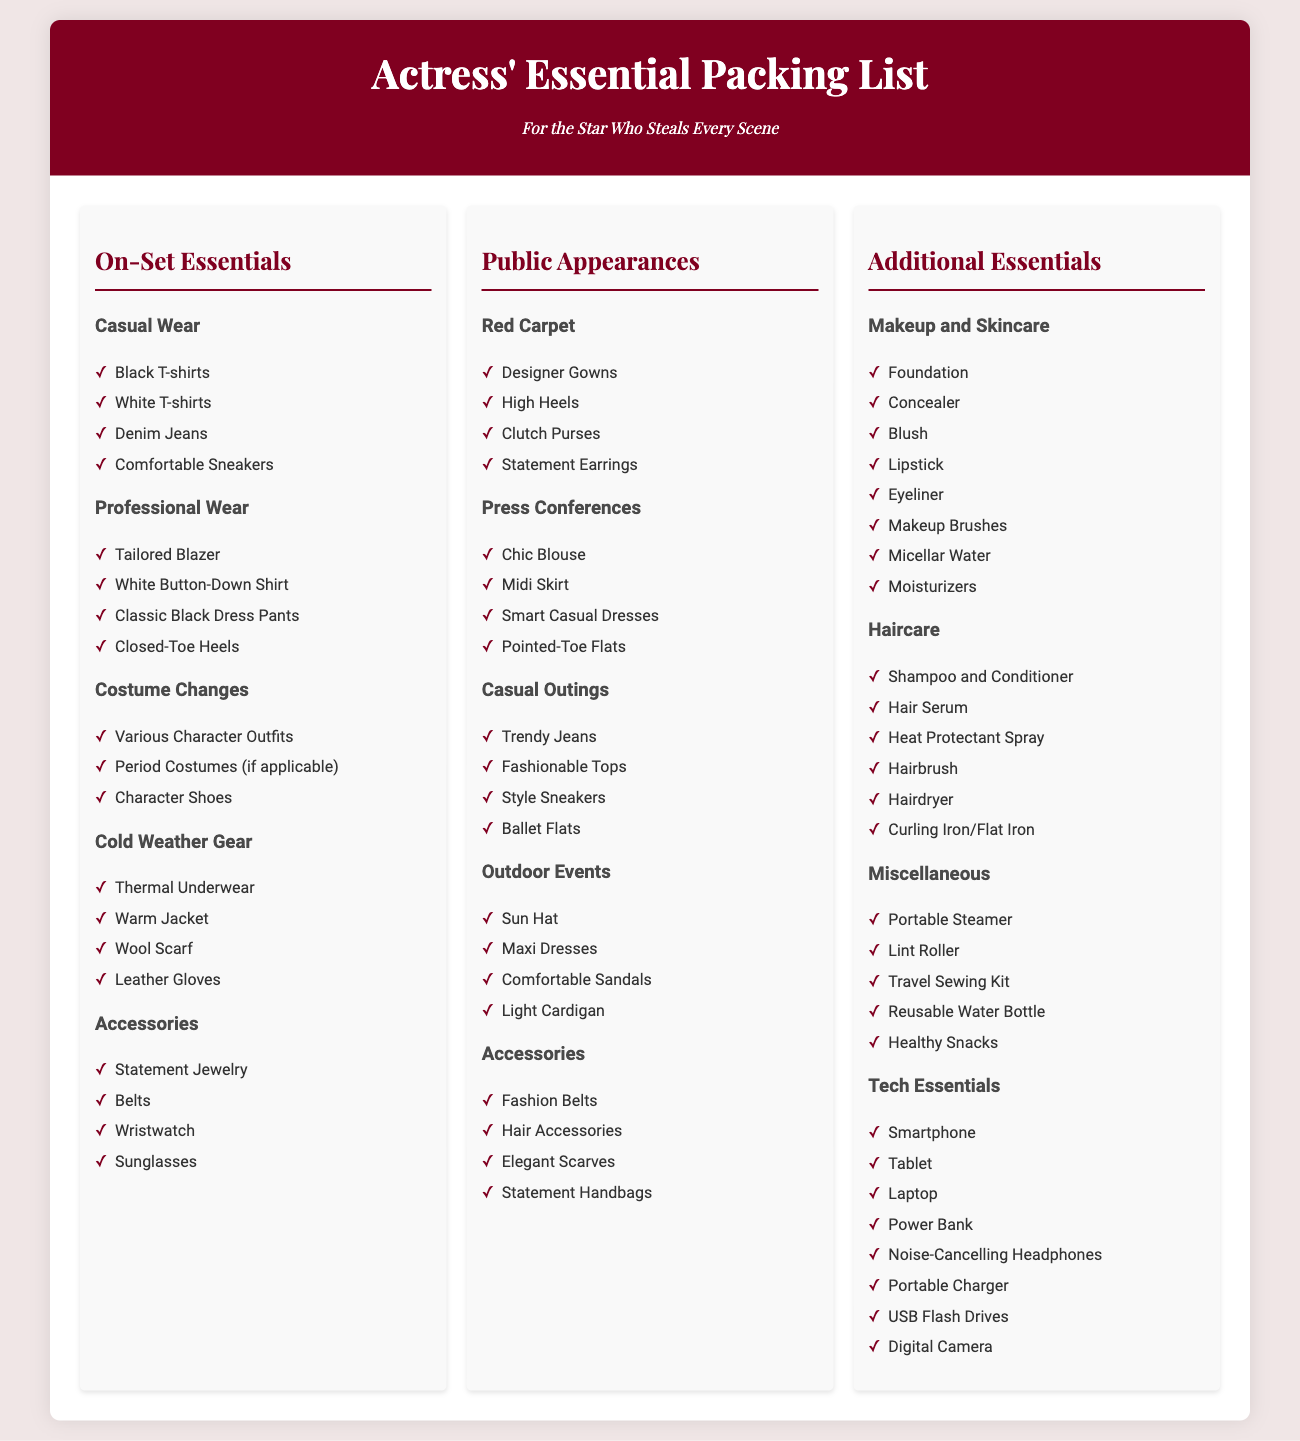what are the categories listed under On-Set Essentials? The categories listed are Casual Wear, Professional Wear, Costume Changes, Cold Weather Gear, and Accessories.
Answer: Casual Wear, Professional Wear, Costume Changes, Cold Weather Gear, Accessories how many outfit types are included under Public Appearances? The outfit types included are Red Carpet, Press Conferences, Casual Outings, Outdoor Events, and Accessories, making a total of five.
Answer: five which item is included in the Make-up and Skincare section? The items listed in this section include Foundation, Concealer, Blush, Lipstick, Eyeliner, Makeup Brushes, and Moisturizers.
Answer: Foundation what is one example of Cold Weather Gear? Items in the Cold Weather Gear include Thermal Underwear, Warm Jacket, Wool Scarf, and Leather Gloves.
Answer: Warm Jacket which category contains various character outfits? Various Character Outfits are included in the Costume Changes section under On-Set Essentials.
Answer: Costume Changes how many items are listed under Haircare? There are six items listed under Haircare: Shampoo and Conditioner, Hair Serum, Heat Protectant Spray, Hairbrush, Hairdryer, and Curling Iron/Flat Iron.
Answer: six what is one type of footwear mentioned in the Red Carpet section? The footwear mentioned is High Heels.
Answer: High Heels which accessory is listed for Public Appearances? Accessories mentioned include Fashion Belts, Hair Accessories, Elegant Scarves, and Statement Handbags.
Answer: Statement Handbags 